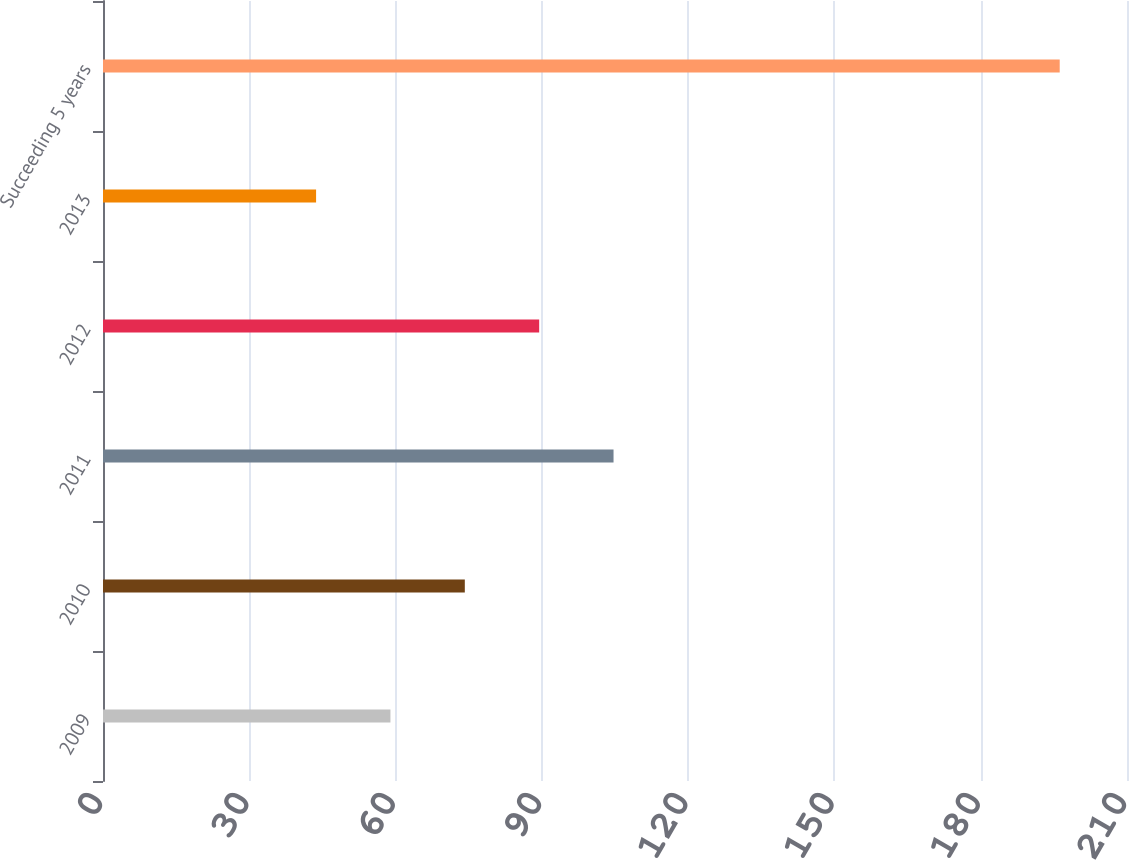Convert chart. <chart><loc_0><loc_0><loc_500><loc_500><bar_chart><fcel>2009<fcel>2010<fcel>2011<fcel>2012<fcel>2013<fcel>Succeeding 5 years<nl><fcel>58.95<fcel>74.2<fcel>104.7<fcel>89.45<fcel>43.7<fcel>196.2<nl></chart> 